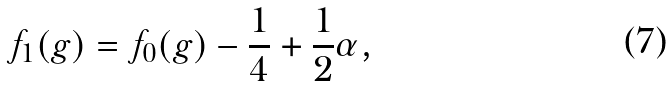<formula> <loc_0><loc_0><loc_500><loc_500>f _ { 1 } ( g ) = f _ { 0 } ( g ) - \frac { 1 } { 4 } + \frac { 1 } { 2 } \alpha ,</formula> 